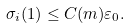<formula> <loc_0><loc_0><loc_500><loc_500>\sigma _ { i } ( 1 ) \leq C ( m ) \varepsilon _ { 0 } .</formula> 